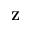Convert formula to latex. <formula><loc_0><loc_0><loc_500><loc_500>Z</formula> 